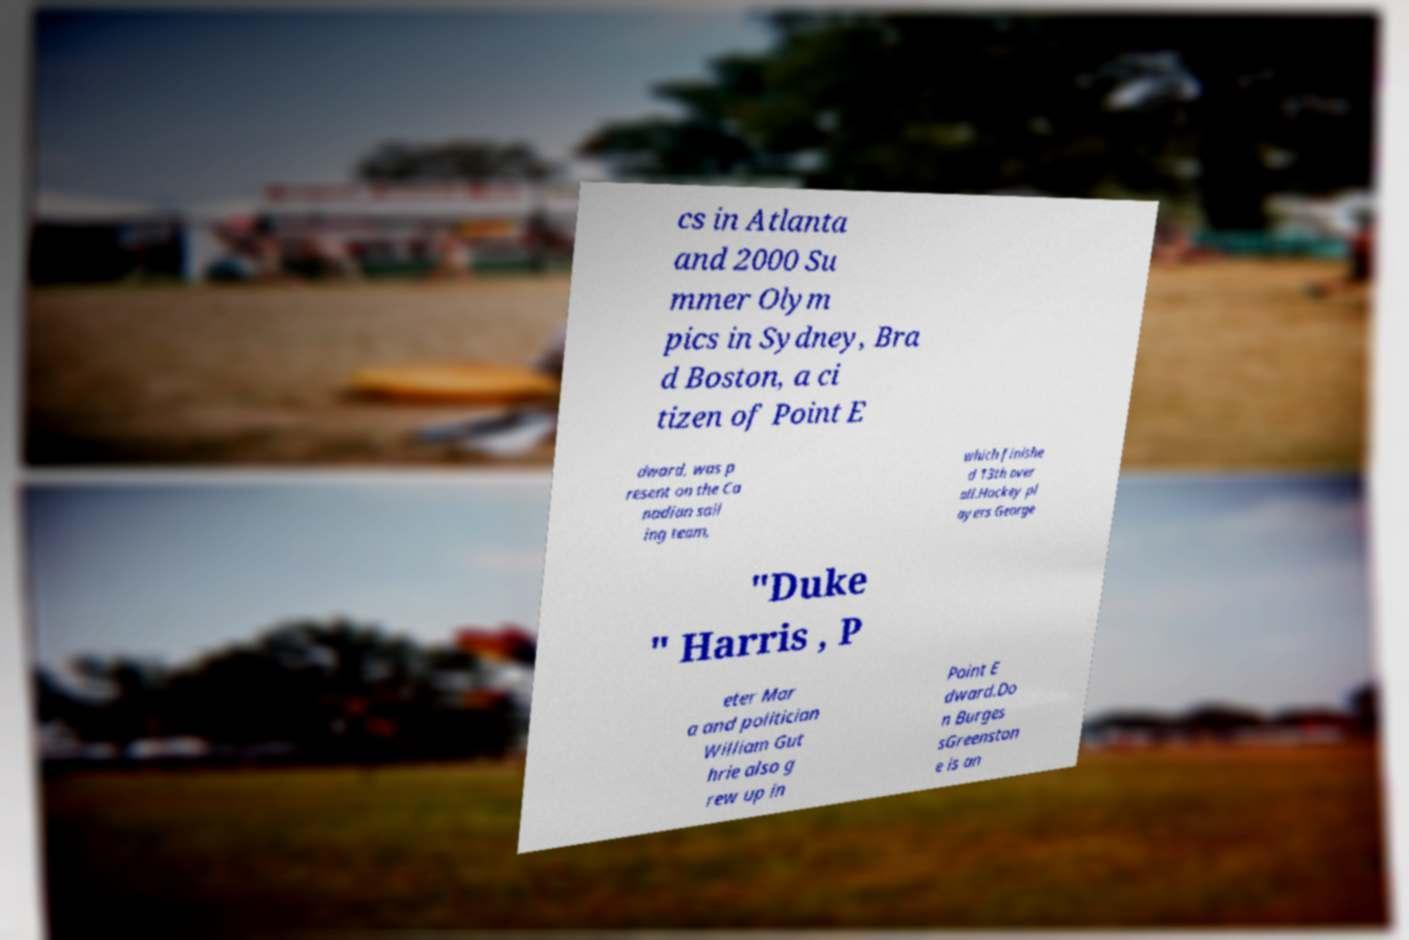For documentation purposes, I need the text within this image transcribed. Could you provide that? cs in Atlanta and 2000 Su mmer Olym pics in Sydney, Bra d Boston, a ci tizen of Point E dward, was p resent on the Ca nadian sail ing team, which finishe d 13th over all.Hockey pl ayers George "Duke " Harris , P eter Mar a and politician William Gut hrie also g rew up in Point E dward.Do n Burges sGreenston e is an 